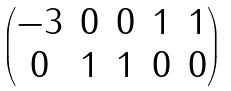Convert formula to latex. <formula><loc_0><loc_0><loc_500><loc_500>\begin{pmatrix} - 3 & 0 & 0 & 1 & 1 \\ 0 & 1 & 1 & 0 & 0 \end{pmatrix}</formula> 